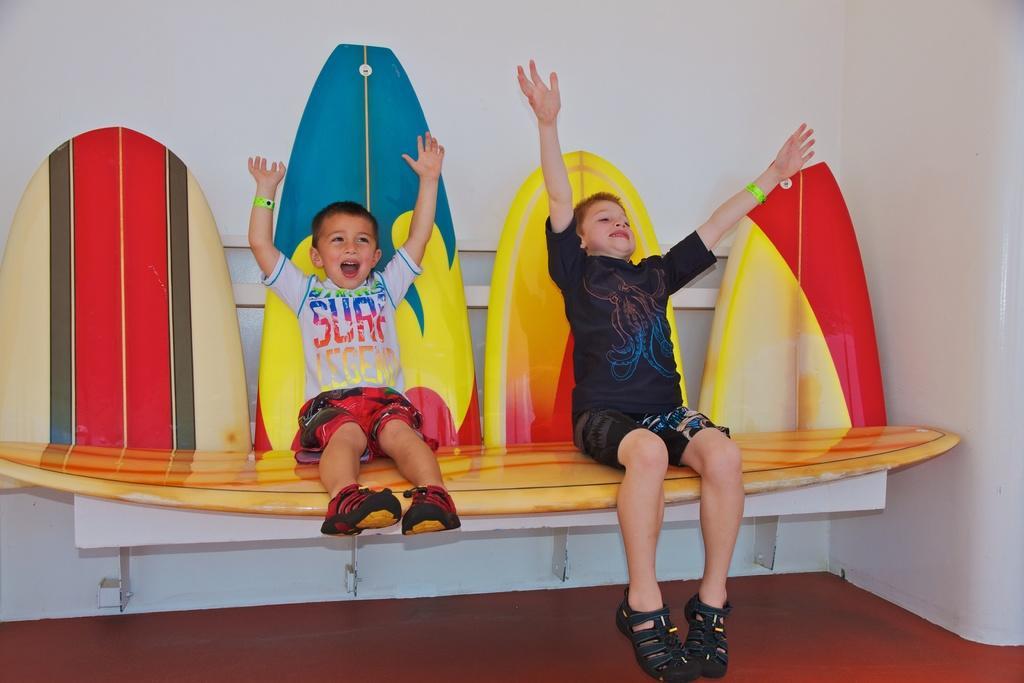How would you summarize this image in a sentence or two? In this image in the center there are two boys who are sitting on skateboard, and in the background there is a wall at the bottom there is a floor. 